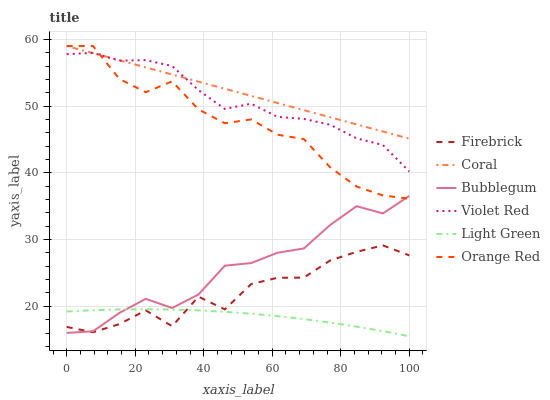Does Light Green have the minimum area under the curve?
Answer yes or no. Yes. Does Coral have the maximum area under the curve?
Answer yes or no. Yes. Does Firebrick have the minimum area under the curve?
Answer yes or no. No. Does Firebrick have the maximum area under the curve?
Answer yes or no. No. Is Coral the smoothest?
Answer yes or no. Yes. Is Firebrick the roughest?
Answer yes or no. Yes. Is Bubblegum the smoothest?
Answer yes or no. No. Is Bubblegum the roughest?
Answer yes or no. No. Does Light Green have the lowest value?
Answer yes or no. Yes. Does Firebrick have the lowest value?
Answer yes or no. No. Does Coral have the highest value?
Answer yes or no. Yes. Does Firebrick have the highest value?
Answer yes or no. No. Is Firebrick less than Violet Red?
Answer yes or no. Yes. Is Violet Red greater than Bubblegum?
Answer yes or no. Yes. Does Coral intersect Violet Red?
Answer yes or no. Yes. Is Coral less than Violet Red?
Answer yes or no. No. Is Coral greater than Violet Red?
Answer yes or no. No. Does Firebrick intersect Violet Red?
Answer yes or no. No. 